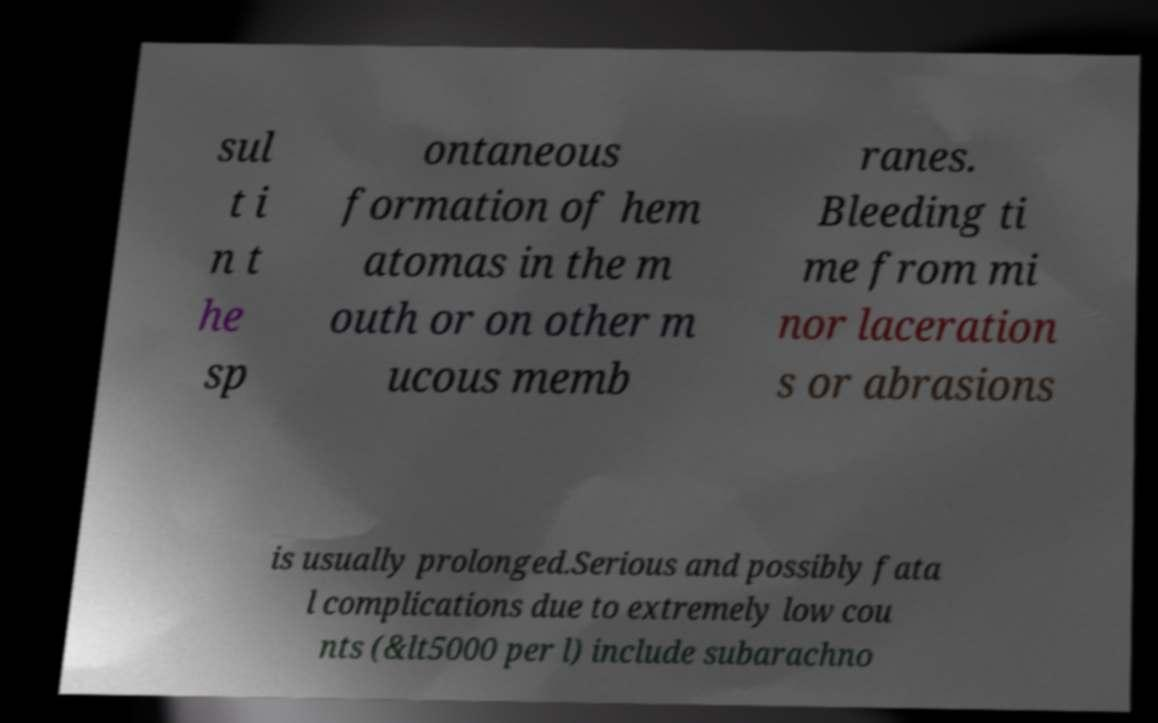Could you extract and type out the text from this image? sul t i n t he sp ontaneous formation of hem atomas in the m outh or on other m ucous memb ranes. Bleeding ti me from mi nor laceration s or abrasions is usually prolonged.Serious and possibly fata l complications due to extremely low cou nts (&lt5000 per l) include subarachno 